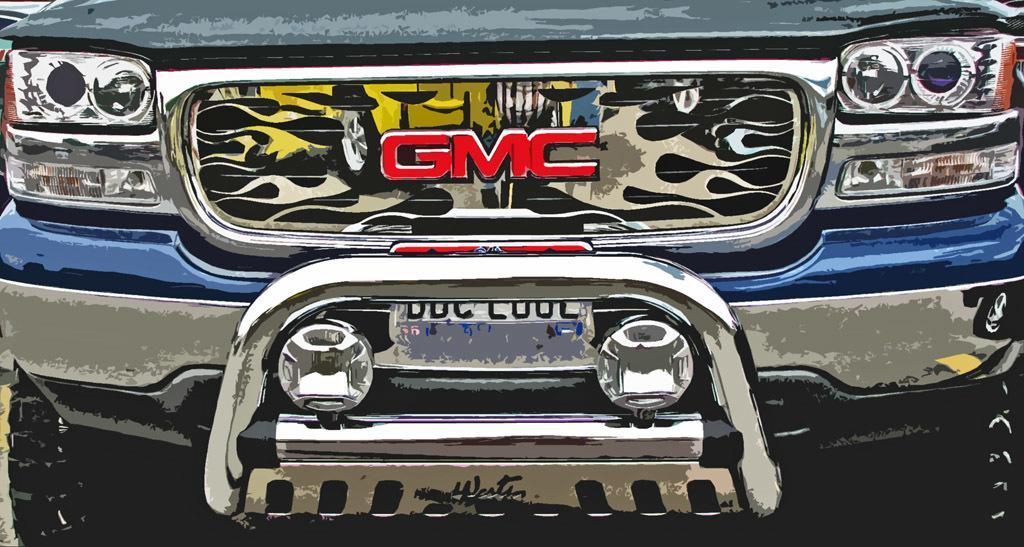Can you describe this image briefly? We can see vehicle, headlights and number plate. 